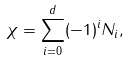<formula> <loc_0><loc_0><loc_500><loc_500>\chi = \sum _ { i = 0 } ^ { d } ( - 1 ) ^ { i } N _ { i } ,</formula> 